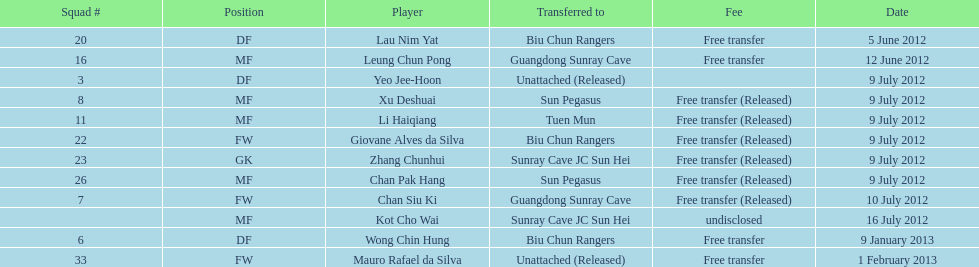Li haiqiang and xu deshuai both occupied which role? MF. 